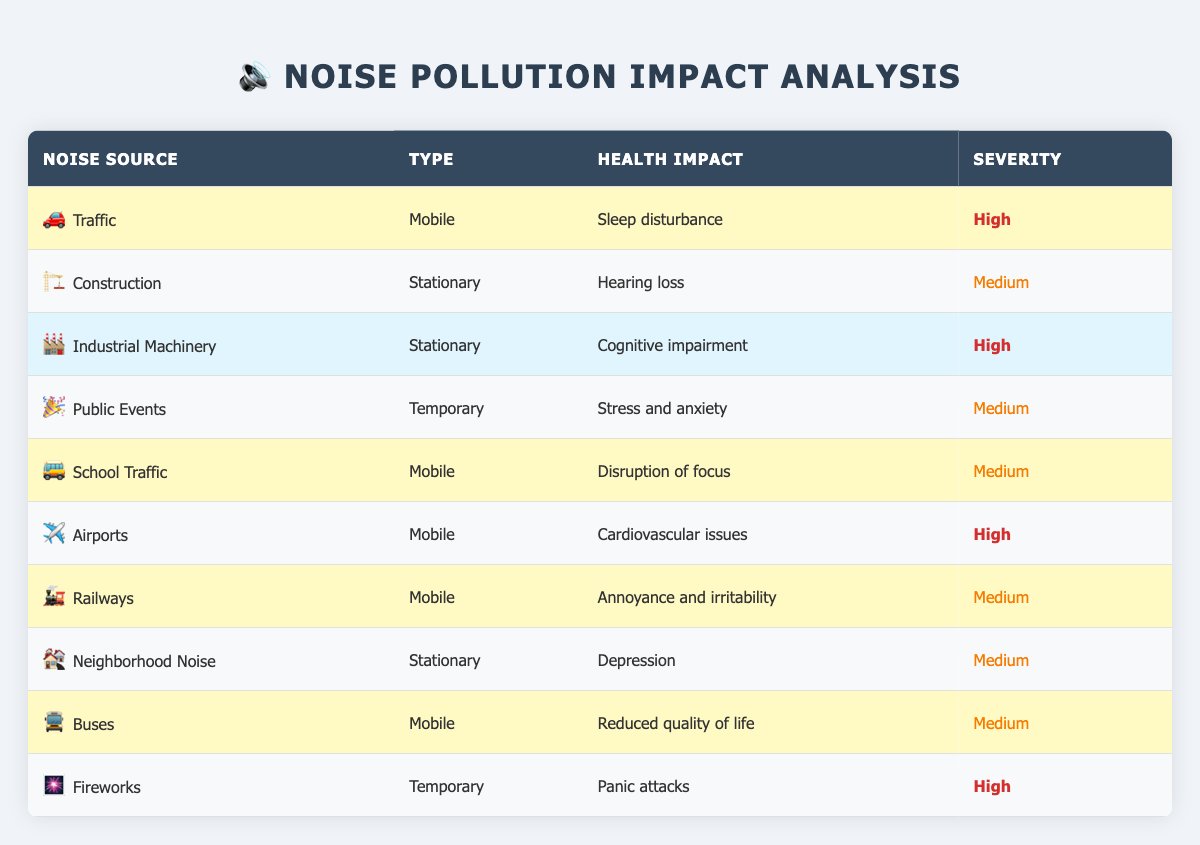What is the health impact of "Traffic"? The table shows that the health impact of "Traffic" is "Sleep disturbance". This can be directly found in the row corresponding to "Traffic" under the "Health Impact" column.
Answer: Sleep disturbance Which noise sources have a "High" severity impact on health? By scanning the "Severity" column of the table, we find that the "Traffic," "Industrial Machinery," "Airports," and "Fireworks" sources are marked as "High." These can be listed directly from their respective rows.
Answer: Traffic, Industrial Machinery, Airports, Fireworks How many noise sources cause "Medium" severity impacts? We count the noise sources that have a "Medium" severity impact in the table by checking each row. There are six such sources: "Construction," "Public Events," "School Traffic," "Railways," "Neighborhood Noise," and "Buses."
Answer: 6 Is "Hearing loss" associated with a "Mobile" type of noise source? Looking at the table, "Hearing loss" is associated with "Construction," which is a "Stationary" type. None of the "Mobile" types list "Hearing loss" for their health impacts. Therefore, the answer is no.
Answer: No What is the total number of health impacts listed for "Temporary" noise sources? The table lists two sources as "Temporary" which are "Public Events" and "Fireworks," each of which has specific health impacts. Therefore, the total count of health impacts represented for "Temporary" is 2.
Answer: 2 Which type of noise source has the highest number of associated health impacts? Checking the “Type” column and counting each type: "Mobile" has 5 impacts (Traffic, School Traffic, Airports, Railways, and Buses), "Stationary" has 4 impacts (Construction, Industrial Machinery, Neighborhood Noise), and "Temporary" has 2 impacts. Thus, "Mobile" has the highest number.
Answer: Mobile Is "Disruption of focus" associated with "Stationary" noise sources? Referring to the table, "Disruption of focus" is tied to "School Traffic," which is classified as a "Mobile" source. Thus, it is not associated with "Stationary" sources.
Answer: No Which noise source has impacts listed as "Annoyance and irritability" and what is its severity? In the table, "Railways" is the source associated with the impact "Annoyance and irritability." Looking at its row, the severity is categorized as "Medium." Thus, the answer includes both the source and the severity.
Answer: Railways, Medium 